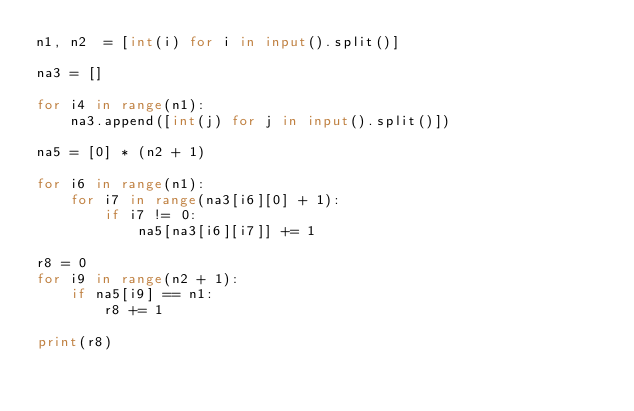Convert code to text. <code><loc_0><loc_0><loc_500><loc_500><_Python_>n1, n2  = [int(i) for i in input().split()]

na3 = []

for i4 in range(n1):
    na3.append([int(j) for j in input().split()])

na5 = [0] * (n2 + 1)

for i6 in range(n1):
    for i7 in range(na3[i6][0] + 1):
        if i7 != 0:
            na5[na3[i6][i7]] += 1

r8 = 0
for i9 in range(n2 + 1):
    if na5[i9] == n1:
        r8 += 1

print(r8)</code> 